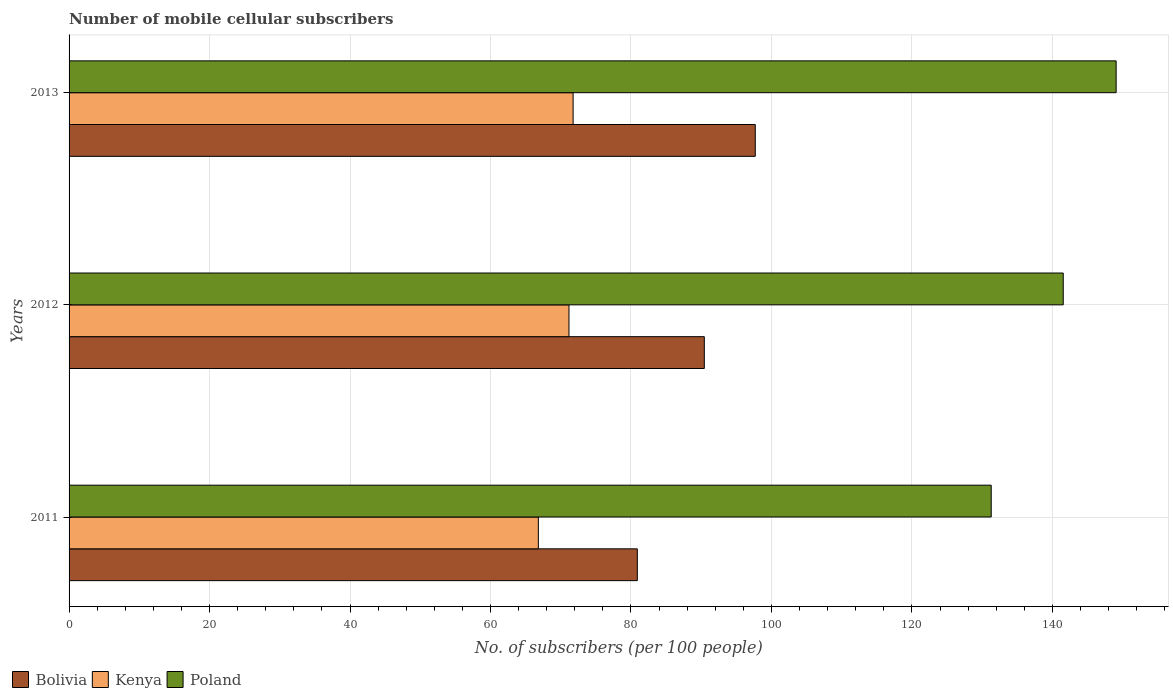How many different coloured bars are there?
Make the answer very short. 3. How many bars are there on the 2nd tick from the bottom?
Offer a terse response. 3. In how many cases, is the number of bars for a given year not equal to the number of legend labels?
Provide a succinct answer. 0. What is the number of mobile cellular subscribers in Kenya in 2012?
Give a very brief answer. 71.17. Across all years, what is the maximum number of mobile cellular subscribers in Bolivia?
Provide a succinct answer. 97.7. Across all years, what is the minimum number of mobile cellular subscribers in Poland?
Offer a very short reply. 131.29. In which year was the number of mobile cellular subscribers in Bolivia minimum?
Make the answer very short. 2011. What is the total number of mobile cellular subscribers in Kenya in the graph?
Your response must be concise. 209.75. What is the difference between the number of mobile cellular subscribers in Kenya in 2012 and that in 2013?
Give a very brief answer. -0.59. What is the difference between the number of mobile cellular subscribers in Bolivia in 2013 and the number of mobile cellular subscribers in Kenya in 2012?
Give a very brief answer. 26.53. What is the average number of mobile cellular subscribers in Bolivia per year?
Provide a short and direct response. 89.68. In the year 2013, what is the difference between the number of mobile cellular subscribers in Bolivia and number of mobile cellular subscribers in Poland?
Give a very brief answer. -51.38. In how many years, is the number of mobile cellular subscribers in Bolivia greater than 88 ?
Provide a short and direct response. 2. What is the ratio of the number of mobile cellular subscribers in Poland in 2012 to that in 2013?
Keep it short and to the point. 0.95. What is the difference between the highest and the second highest number of mobile cellular subscribers in Poland?
Make the answer very short. 7.53. What is the difference between the highest and the lowest number of mobile cellular subscribers in Kenya?
Provide a short and direct response. 4.95. What does the 1st bar from the top in 2011 represents?
Give a very brief answer. Poland. How many years are there in the graph?
Provide a succinct answer. 3. Are the values on the major ticks of X-axis written in scientific E-notation?
Offer a terse response. No. Does the graph contain grids?
Ensure brevity in your answer.  Yes. How many legend labels are there?
Ensure brevity in your answer.  3. How are the legend labels stacked?
Offer a very short reply. Horizontal. What is the title of the graph?
Your response must be concise. Number of mobile cellular subscribers. Does "Burkina Faso" appear as one of the legend labels in the graph?
Ensure brevity in your answer.  No. What is the label or title of the X-axis?
Ensure brevity in your answer.  No. of subscribers (per 100 people). What is the label or title of the Y-axis?
Keep it short and to the point. Years. What is the No. of subscribers (per 100 people) of Bolivia in 2011?
Provide a short and direct response. 80.91. What is the No. of subscribers (per 100 people) in Kenya in 2011?
Your answer should be compact. 66.81. What is the No. of subscribers (per 100 people) in Poland in 2011?
Provide a succinct answer. 131.29. What is the No. of subscribers (per 100 people) in Bolivia in 2012?
Give a very brief answer. 90.44. What is the No. of subscribers (per 100 people) of Kenya in 2012?
Offer a very short reply. 71.17. What is the No. of subscribers (per 100 people) in Poland in 2012?
Ensure brevity in your answer.  141.55. What is the No. of subscribers (per 100 people) of Bolivia in 2013?
Your response must be concise. 97.7. What is the No. of subscribers (per 100 people) in Kenya in 2013?
Offer a terse response. 71.76. What is the No. of subscribers (per 100 people) in Poland in 2013?
Make the answer very short. 149.08. Across all years, what is the maximum No. of subscribers (per 100 people) in Bolivia?
Ensure brevity in your answer.  97.7. Across all years, what is the maximum No. of subscribers (per 100 people) in Kenya?
Your answer should be compact. 71.76. Across all years, what is the maximum No. of subscribers (per 100 people) in Poland?
Your answer should be compact. 149.08. Across all years, what is the minimum No. of subscribers (per 100 people) in Bolivia?
Give a very brief answer. 80.91. Across all years, what is the minimum No. of subscribers (per 100 people) in Kenya?
Keep it short and to the point. 66.81. Across all years, what is the minimum No. of subscribers (per 100 people) of Poland?
Provide a succinct answer. 131.29. What is the total No. of subscribers (per 100 people) in Bolivia in the graph?
Your answer should be compact. 269.05. What is the total No. of subscribers (per 100 people) of Kenya in the graph?
Provide a short and direct response. 209.75. What is the total No. of subscribers (per 100 people) of Poland in the graph?
Provide a short and direct response. 421.92. What is the difference between the No. of subscribers (per 100 people) in Bolivia in 2011 and that in 2012?
Provide a short and direct response. -9.54. What is the difference between the No. of subscribers (per 100 people) of Kenya in 2011 and that in 2012?
Provide a short and direct response. -4.36. What is the difference between the No. of subscribers (per 100 people) in Poland in 2011 and that in 2012?
Give a very brief answer. -10.25. What is the difference between the No. of subscribers (per 100 people) in Bolivia in 2011 and that in 2013?
Offer a terse response. -16.79. What is the difference between the No. of subscribers (per 100 people) of Kenya in 2011 and that in 2013?
Your answer should be very brief. -4.95. What is the difference between the No. of subscribers (per 100 people) in Poland in 2011 and that in 2013?
Your answer should be compact. -17.78. What is the difference between the No. of subscribers (per 100 people) of Bolivia in 2012 and that in 2013?
Keep it short and to the point. -7.26. What is the difference between the No. of subscribers (per 100 people) of Kenya in 2012 and that in 2013?
Offer a very short reply. -0.59. What is the difference between the No. of subscribers (per 100 people) in Poland in 2012 and that in 2013?
Your answer should be compact. -7.53. What is the difference between the No. of subscribers (per 100 people) in Bolivia in 2011 and the No. of subscribers (per 100 people) in Kenya in 2012?
Your answer should be very brief. 9.73. What is the difference between the No. of subscribers (per 100 people) of Bolivia in 2011 and the No. of subscribers (per 100 people) of Poland in 2012?
Your response must be concise. -60.64. What is the difference between the No. of subscribers (per 100 people) in Kenya in 2011 and the No. of subscribers (per 100 people) in Poland in 2012?
Your response must be concise. -74.73. What is the difference between the No. of subscribers (per 100 people) in Bolivia in 2011 and the No. of subscribers (per 100 people) in Kenya in 2013?
Offer a terse response. 9.14. What is the difference between the No. of subscribers (per 100 people) of Bolivia in 2011 and the No. of subscribers (per 100 people) of Poland in 2013?
Give a very brief answer. -68.17. What is the difference between the No. of subscribers (per 100 people) of Kenya in 2011 and the No. of subscribers (per 100 people) of Poland in 2013?
Your answer should be compact. -82.26. What is the difference between the No. of subscribers (per 100 people) in Bolivia in 2012 and the No. of subscribers (per 100 people) in Kenya in 2013?
Ensure brevity in your answer.  18.68. What is the difference between the No. of subscribers (per 100 people) of Bolivia in 2012 and the No. of subscribers (per 100 people) of Poland in 2013?
Keep it short and to the point. -58.63. What is the difference between the No. of subscribers (per 100 people) in Kenya in 2012 and the No. of subscribers (per 100 people) in Poland in 2013?
Ensure brevity in your answer.  -77.9. What is the average No. of subscribers (per 100 people) of Bolivia per year?
Your response must be concise. 89.68. What is the average No. of subscribers (per 100 people) in Kenya per year?
Offer a terse response. 69.92. What is the average No. of subscribers (per 100 people) of Poland per year?
Your response must be concise. 140.64. In the year 2011, what is the difference between the No. of subscribers (per 100 people) of Bolivia and No. of subscribers (per 100 people) of Kenya?
Ensure brevity in your answer.  14.09. In the year 2011, what is the difference between the No. of subscribers (per 100 people) of Bolivia and No. of subscribers (per 100 people) of Poland?
Your response must be concise. -50.39. In the year 2011, what is the difference between the No. of subscribers (per 100 people) of Kenya and No. of subscribers (per 100 people) of Poland?
Offer a terse response. -64.48. In the year 2012, what is the difference between the No. of subscribers (per 100 people) in Bolivia and No. of subscribers (per 100 people) in Kenya?
Make the answer very short. 19.27. In the year 2012, what is the difference between the No. of subscribers (per 100 people) of Bolivia and No. of subscribers (per 100 people) of Poland?
Offer a terse response. -51.1. In the year 2012, what is the difference between the No. of subscribers (per 100 people) in Kenya and No. of subscribers (per 100 people) in Poland?
Make the answer very short. -70.37. In the year 2013, what is the difference between the No. of subscribers (per 100 people) in Bolivia and No. of subscribers (per 100 people) in Kenya?
Keep it short and to the point. 25.94. In the year 2013, what is the difference between the No. of subscribers (per 100 people) of Bolivia and No. of subscribers (per 100 people) of Poland?
Give a very brief answer. -51.38. In the year 2013, what is the difference between the No. of subscribers (per 100 people) in Kenya and No. of subscribers (per 100 people) in Poland?
Your answer should be compact. -77.31. What is the ratio of the No. of subscribers (per 100 people) of Bolivia in 2011 to that in 2012?
Make the answer very short. 0.89. What is the ratio of the No. of subscribers (per 100 people) in Kenya in 2011 to that in 2012?
Keep it short and to the point. 0.94. What is the ratio of the No. of subscribers (per 100 people) of Poland in 2011 to that in 2012?
Your answer should be very brief. 0.93. What is the ratio of the No. of subscribers (per 100 people) in Bolivia in 2011 to that in 2013?
Offer a terse response. 0.83. What is the ratio of the No. of subscribers (per 100 people) of Kenya in 2011 to that in 2013?
Offer a terse response. 0.93. What is the ratio of the No. of subscribers (per 100 people) in Poland in 2011 to that in 2013?
Offer a very short reply. 0.88. What is the ratio of the No. of subscribers (per 100 people) of Bolivia in 2012 to that in 2013?
Give a very brief answer. 0.93. What is the ratio of the No. of subscribers (per 100 people) in Poland in 2012 to that in 2013?
Offer a very short reply. 0.95. What is the difference between the highest and the second highest No. of subscribers (per 100 people) of Bolivia?
Keep it short and to the point. 7.26. What is the difference between the highest and the second highest No. of subscribers (per 100 people) of Kenya?
Offer a terse response. 0.59. What is the difference between the highest and the second highest No. of subscribers (per 100 people) in Poland?
Give a very brief answer. 7.53. What is the difference between the highest and the lowest No. of subscribers (per 100 people) in Bolivia?
Your answer should be very brief. 16.79. What is the difference between the highest and the lowest No. of subscribers (per 100 people) in Kenya?
Offer a very short reply. 4.95. What is the difference between the highest and the lowest No. of subscribers (per 100 people) in Poland?
Provide a short and direct response. 17.78. 